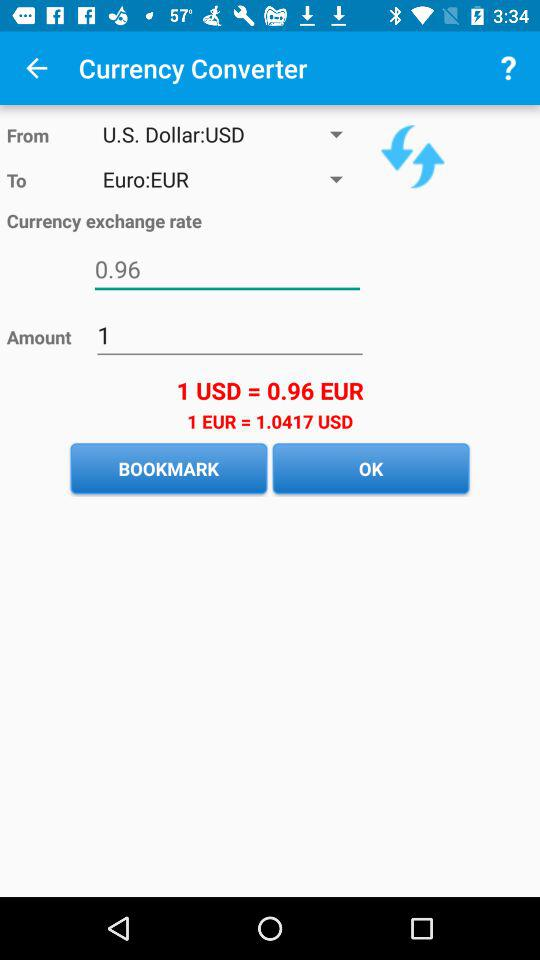How much more is 1 EUR than 1 USD?
Answer the question using a single word or phrase. 0.0417 